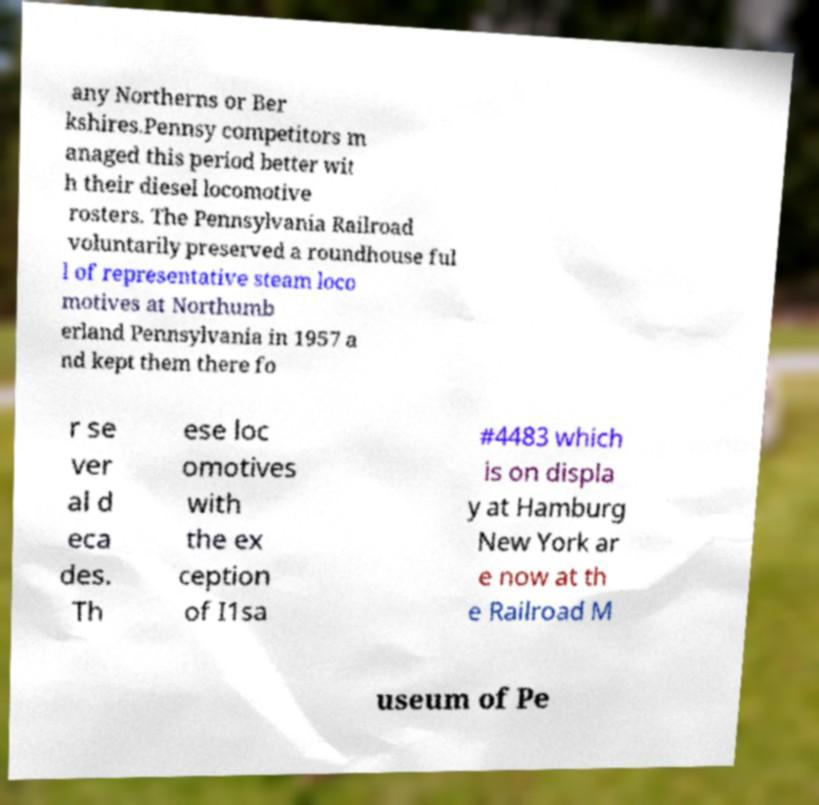Please read and relay the text visible in this image. What does it say? any Northerns or Ber kshires.Pennsy competitors m anaged this period better wit h their diesel locomotive rosters. The Pennsylvania Railroad voluntarily preserved a roundhouse ful l of representative steam loco motives at Northumb erland Pennsylvania in 1957 a nd kept them there fo r se ver al d eca des. Th ese loc omotives with the ex ception of I1sa #4483 which is on displa y at Hamburg New York ar e now at th e Railroad M useum of Pe 